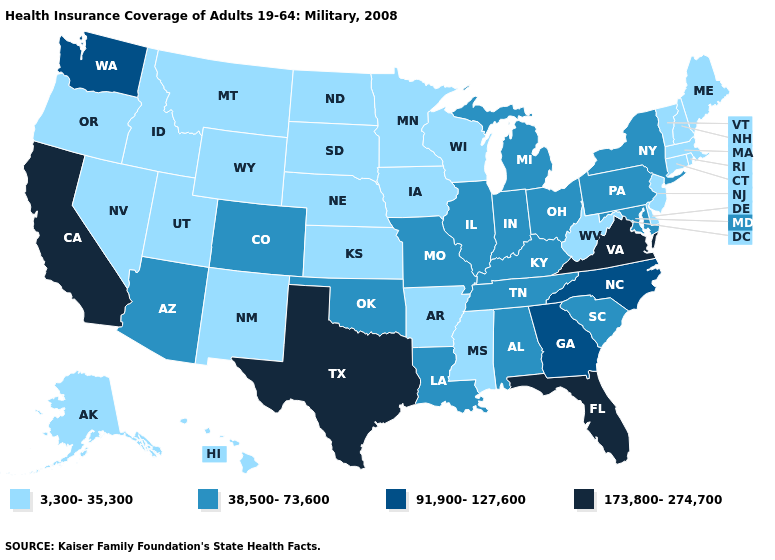Among the states that border South Carolina , which have the highest value?
Keep it brief. Georgia, North Carolina. Name the states that have a value in the range 38,500-73,600?
Give a very brief answer. Alabama, Arizona, Colorado, Illinois, Indiana, Kentucky, Louisiana, Maryland, Michigan, Missouri, New York, Ohio, Oklahoma, Pennsylvania, South Carolina, Tennessee. What is the value of Maryland?
Concise answer only. 38,500-73,600. Which states have the lowest value in the USA?
Be succinct. Alaska, Arkansas, Connecticut, Delaware, Hawaii, Idaho, Iowa, Kansas, Maine, Massachusetts, Minnesota, Mississippi, Montana, Nebraska, Nevada, New Hampshire, New Jersey, New Mexico, North Dakota, Oregon, Rhode Island, South Dakota, Utah, Vermont, West Virginia, Wisconsin, Wyoming. Does Kansas have a lower value than Missouri?
Be succinct. Yes. Which states have the lowest value in the West?
Write a very short answer. Alaska, Hawaii, Idaho, Montana, Nevada, New Mexico, Oregon, Utah, Wyoming. Name the states that have a value in the range 91,900-127,600?
Keep it brief. Georgia, North Carolina, Washington. Name the states that have a value in the range 91,900-127,600?
Give a very brief answer. Georgia, North Carolina, Washington. What is the lowest value in the USA?
Answer briefly. 3,300-35,300. Does the first symbol in the legend represent the smallest category?
Be succinct. Yes. What is the highest value in states that border Colorado?
Concise answer only. 38,500-73,600. Does Delaware have the same value as Georgia?
Concise answer only. No. Does Wisconsin have the highest value in the MidWest?
Give a very brief answer. No. Which states have the lowest value in the USA?
Write a very short answer. Alaska, Arkansas, Connecticut, Delaware, Hawaii, Idaho, Iowa, Kansas, Maine, Massachusetts, Minnesota, Mississippi, Montana, Nebraska, Nevada, New Hampshire, New Jersey, New Mexico, North Dakota, Oregon, Rhode Island, South Dakota, Utah, Vermont, West Virginia, Wisconsin, Wyoming. Does the first symbol in the legend represent the smallest category?
Answer briefly. Yes. 